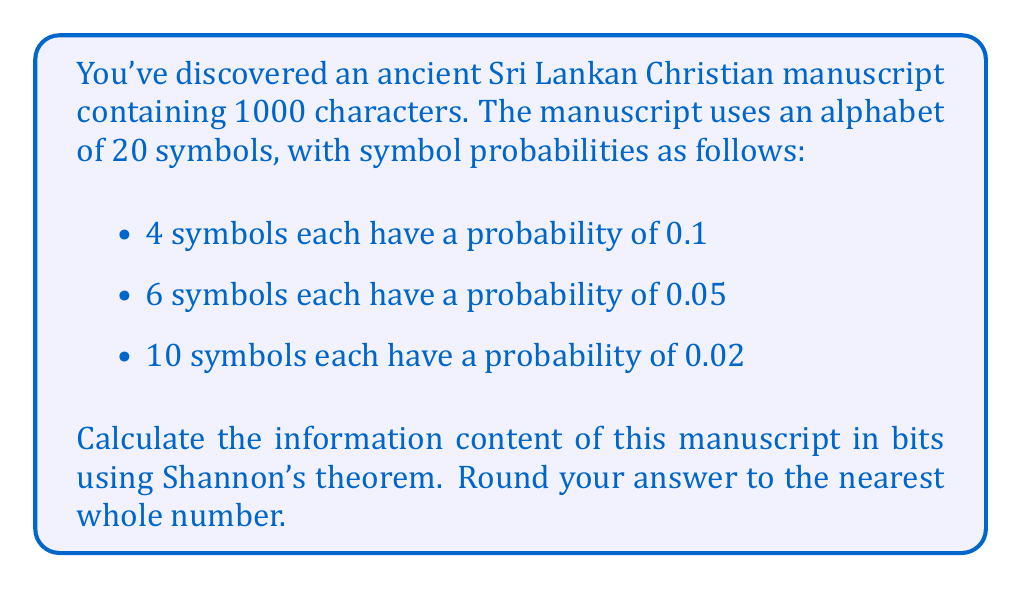Give your solution to this math problem. To solve this problem, we'll use Shannon's theorem for information entropy, which is given by:

$$H = -\sum_{i=1}^{n} p_i \log_2(p_i)$$

Where $H$ is the information entropy in bits, $p_i$ is the probability of each symbol, and $n$ is the number of symbols in the alphabet.

Let's calculate the entropy for each group of symbols:

1. For the 4 symbols with probability 0.1:
   $$H_1 = 4 \cdot (-0.1 \log_2(0.1)) = 4 \cdot 0.332 = 1.328$$

2. For the 6 symbols with probability 0.05:
   $$H_2 = 6 \cdot (-0.05 \log_2(0.05)) = 6 \cdot 0.216 = 1.296$$

3. For the 10 symbols with probability 0.02:
   $$H_3 = 10 \cdot (-0.02 \log_2(0.02)) = 10 \cdot 0.113 = 1.130$$

The total entropy per character is:
$$H_{total} = H_1 + H_2 + H_3 = 1.328 + 1.296 + 1.130 = 3.754 \text{ bits}$$

Since the manuscript contains 1000 characters, the total information content is:

$$\text{Information Content} = 1000 \cdot 3.754 = 3754 \text{ bits}$$

Rounding to the nearest whole number, we get 3754 bits.
Answer: 3754 bits 